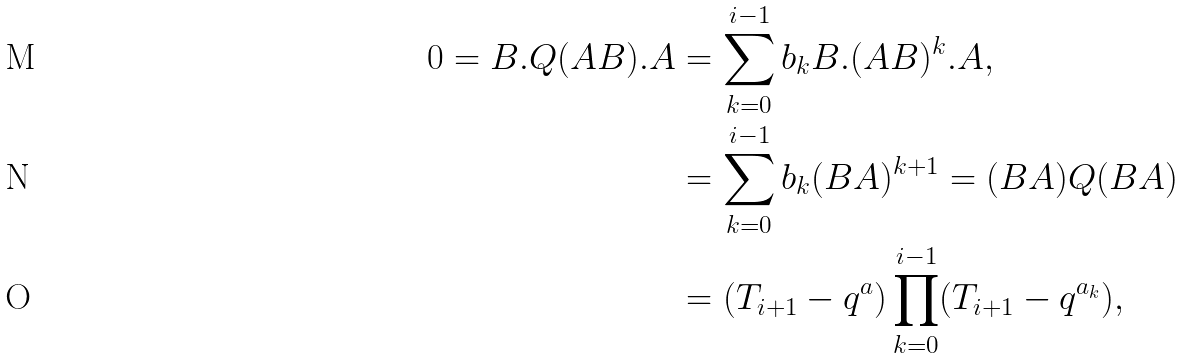Convert formula to latex. <formula><loc_0><loc_0><loc_500><loc_500>0 = B . Q ( A B ) . A & = \sum _ { k = 0 } ^ { i - 1 } b _ { k } B . ( A B ) ^ { k } . A , \\ & = \sum _ { k = 0 } ^ { i - 1 } b _ { k } ( B A ) ^ { k + 1 } = ( B A ) Q ( B A ) \\ & = ( T _ { i + 1 } - q ^ { a } ) \prod _ { k = 0 } ^ { i - 1 } ( T _ { i + 1 } - q ^ { a _ { k } } ) ,</formula> 